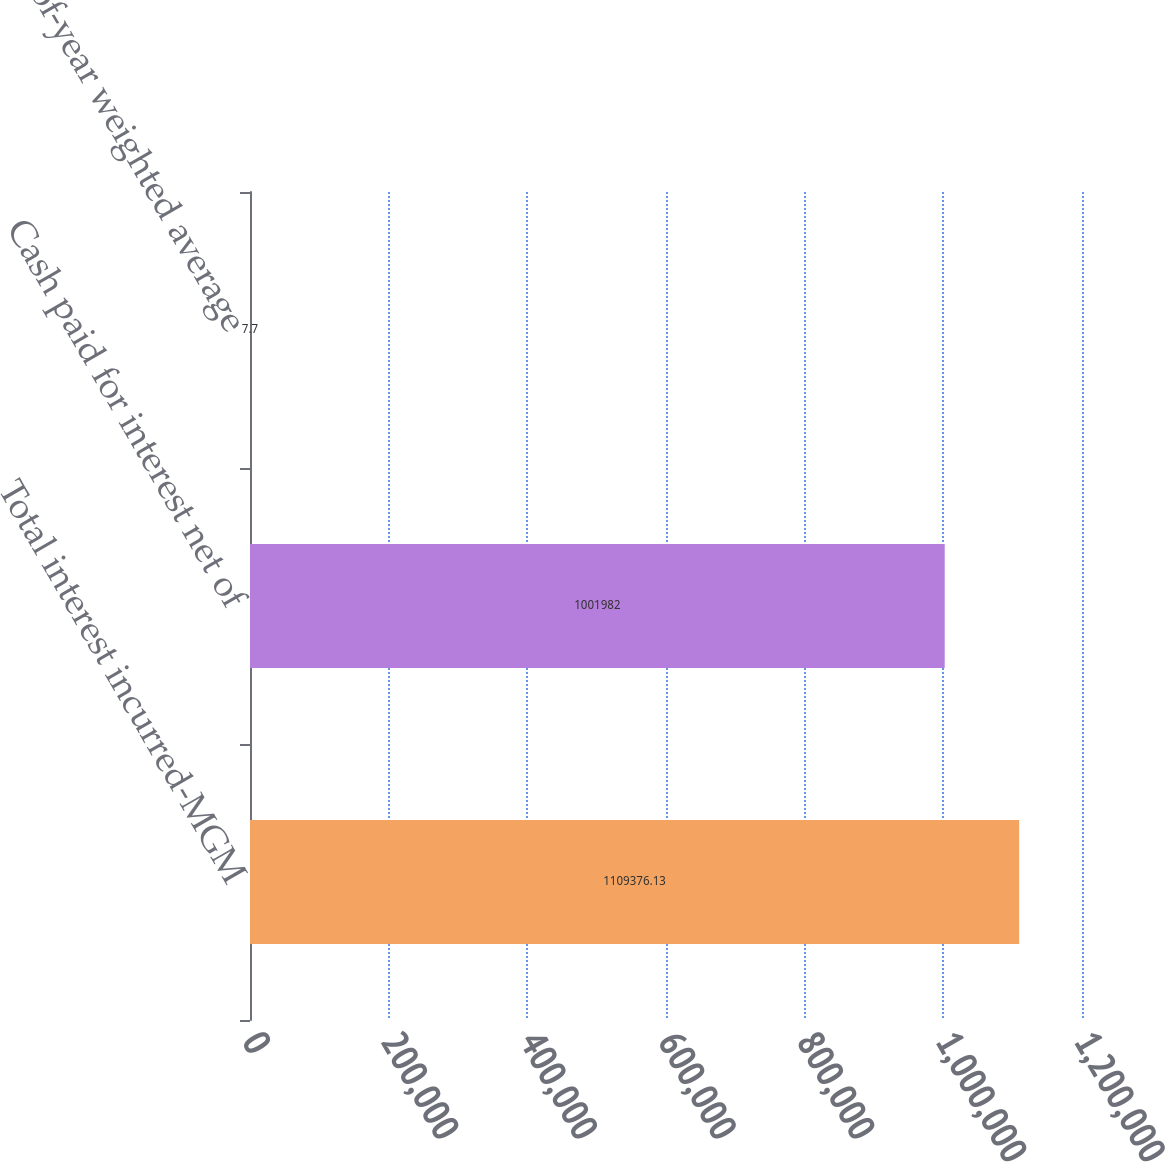<chart> <loc_0><loc_0><loc_500><loc_500><bar_chart><fcel>Total interest incurred-MGM<fcel>Cash paid for interest net of<fcel>End-of-year weighted average<nl><fcel>1.10938e+06<fcel>1.00198e+06<fcel>7.7<nl></chart> 